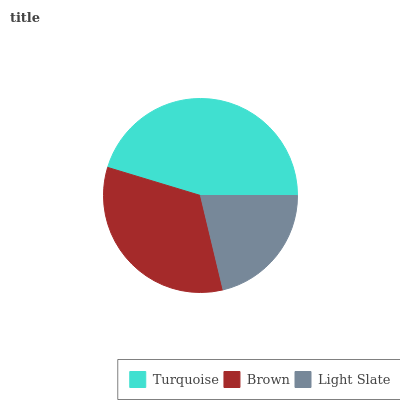Is Light Slate the minimum?
Answer yes or no. Yes. Is Turquoise the maximum?
Answer yes or no. Yes. Is Brown the minimum?
Answer yes or no. No. Is Brown the maximum?
Answer yes or no. No. Is Turquoise greater than Brown?
Answer yes or no. Yes. Is Brown less than Turquoise?
Answer yes or no. Yes. Is Brown greater than Turquoise?
Answer yes or no. No. Is Turquoise less than Brown?
Answer yes or no. No. Is Brown the high median?
Answer yes or no. Yes. Is Brown the low median?
Answer yes or no. Yes. Is Light Slate the high median?
Answer yes or no. No. Is Light Slate the low median?
Answer yes or no. No. 